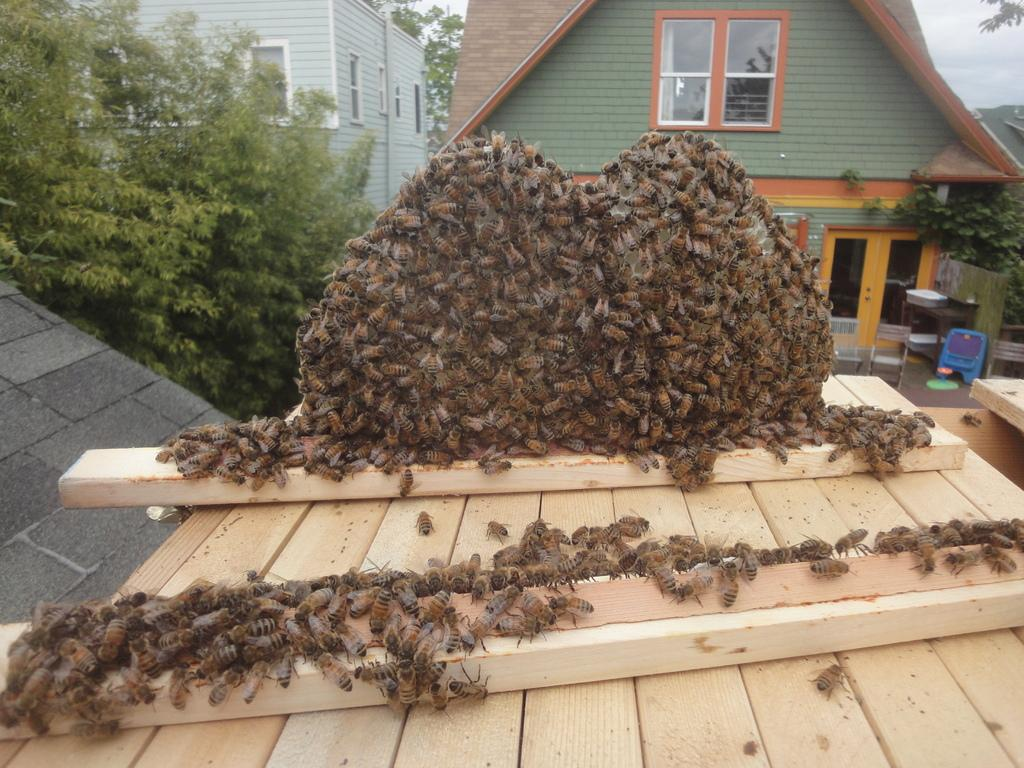What insects can be seen on the wood in the image? There are bees on the wood in the image. What can be seen in the distance behind the wood? There are buildings, trees, and chairs visible in the background of the image. What else is present in the background of the image? There are other objects in the background of the image. What is visible at the top of the image? The sky is visible at the top of the image. What type of nut is being cracked by the bees in the image? There are no nuts present in the image, and the bees are not cracking anything. What sound can be heard from the alarm in the image? There is no alarm present in the image, so no sound can be heard. 